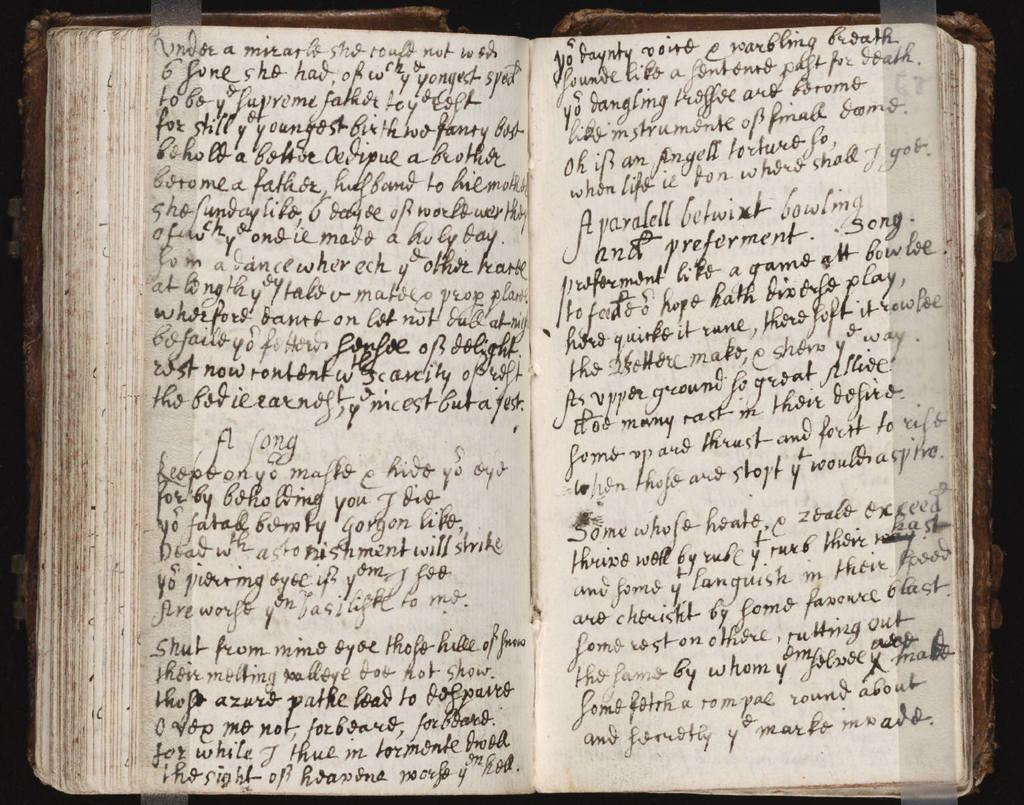Can you describe this image briefly? In this picture we can see a book. We can see text on the papers. We can see transparent tape pasted on both papers. 